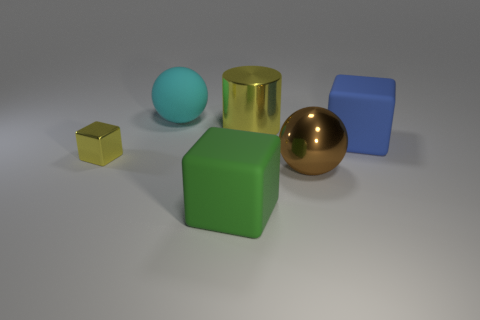Subtract all tiny yellow blocks. How many blocks are left? 2 Add 1 large yellow metallic objects. How many objects exist? 7 Subtract all cyan blocks. Subtract all gray balls. How many blocks are left? 3 Subtract 0 green balls. How many objects are left? 6 Subtract all spheres. How many objects are left? 4 Subtract all big green objects. Subtract all small yellow matte objects. How many objects are left? 5 Add 6 yellow metallic cylinders. How many yellow metallic cylinders are left? 7 Add 6 large yellow metallic objects. How many large yellow metallic objects exist? 7 